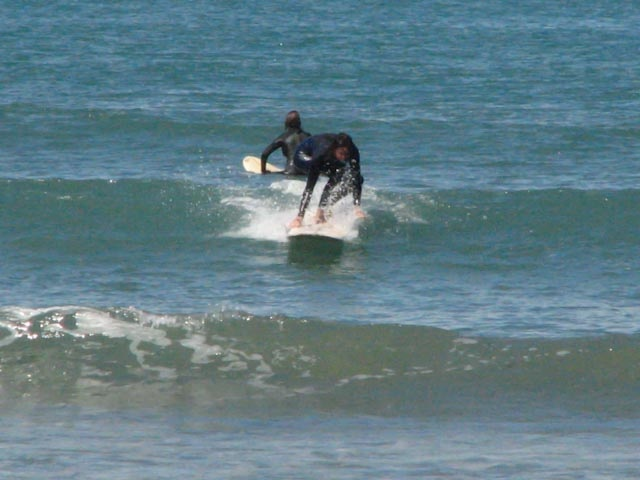Describe the objects in this image and their specific colors. I can see people in teal, black, gray, and darkgray tones, people in teal, black, gray, and beige tones, surfboard in teal, lightgray, gray, black, and darkgray tones, and surfboard in teal, beige, tan, darkgray, and gray tones in this image. 